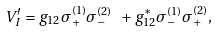<formula> <loc_0><loc_0><loc_500><loc_500>V _ { I } ^ { \prime } = g _ { 1 2 } \sigma _ { + } ^ { ( 1 ) } \sigma _ { - } ^ { ( 2 ) } \ + g _ { 1 2 } ^ { * } \sigma _ { - } ^ { ( 1 ) } \sigma _ { + } ^ { ( 2 ) } ,</formula> 